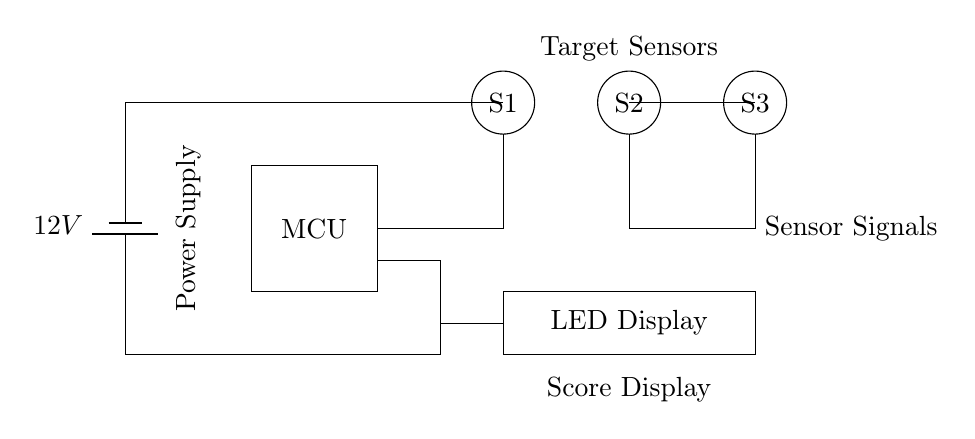What is the power supply voltage? The power supply voltage is labeled in the circuit diagram, specifically indicated next to the battery component. The displayed voltage is 12V.
Answer: 12V What components are used for sensing? The circuit diagram shows three circular components labeled as S1, S2, and S3. These represent the target sensors used in the shooting range.
Answer: S1, S2, S3 How are the sensors connected to the microcontroller? The circuit diagram illustrates a direct connection from the sensors (S1, S2, S3) to the microcontroller (MCU). The wiring shows that the sensor signals flow directly into the MCU for processing.
Answer: Directly connected What indicates the output of the scoring system? The scoring system output is represented by the LED display component, which is labeled accordingly at the bottom of the circuit. This is where the scores will be visually presented.
Answer: LED Display What is the role of the microcontroller in this circuit? The microcontroller (MCU) processes the signals received from the target sensors and then manages the output to the LED display, thereby scoring the targets hit.
Answer: Processing and managing scores How many target sensors are present in the circuit? The circuit diagram clearly depicts three distinct sensor components labeled S1, S2, and S3, confirming that there are a total of three target sensors in the system.
Answer: Three 